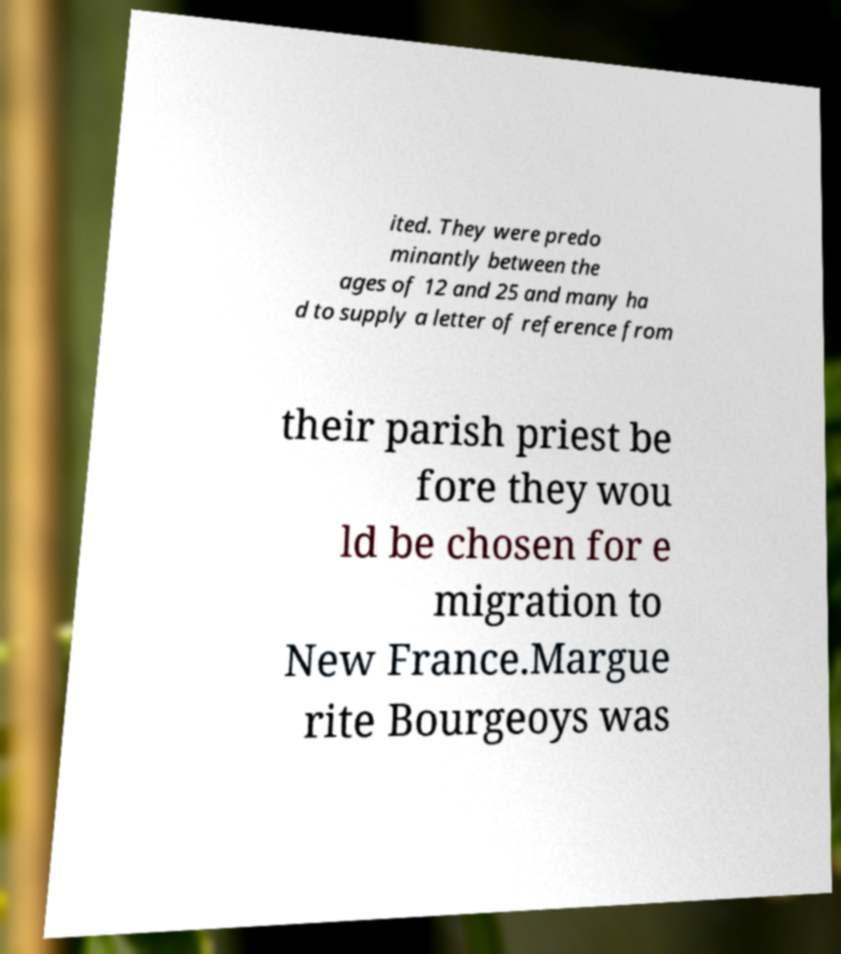Could you assist in decoding the text presented in this image and type it out clearly? ited. They were predo minantly between the ages of 12 and 25 and many ha d to supply a letter of reference from their parish priest be fore they wou ld be chosen for e migration to New France.Margue rite Bourgeoys was 